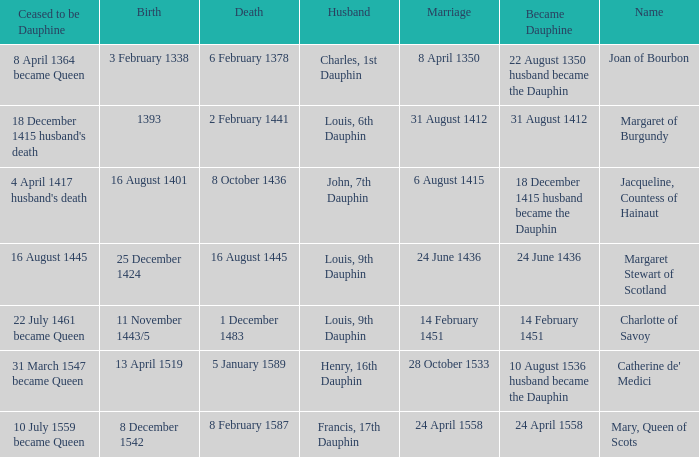Who has a birth of 16 august 1401? Jacqueline, Countess of Hainaut. 